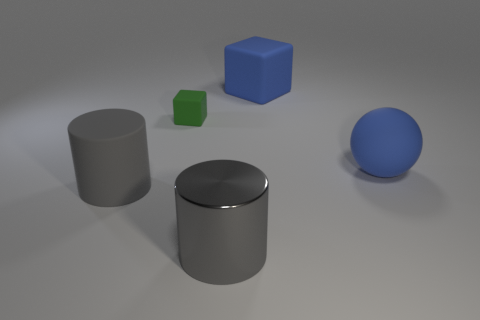Does the large rubber cube have the same color as the matte ball?
Your answer should be compact. Yes. Are there any other things that have the same size as the green block?
Your response must be concise. No. There is a big rubber thing that is behind the big blue sphere; what is its color?
Provide a short and direct response. Blue. What is the size of the gray object that is the same material as the big block?
Make the answer very short. Large. What number of big cylinders are behind the object to the left of the small rubber object?
Make the answer very short. 0. There is a blue rubber ball; what number of big blue objects are in front of it?
Make the answer very short. 0. What color is the big matte object that is in front of the blue matte thing that is on the right side of the large blue rubber thing behind the blue sphere?
Offer a terse response. Gray. Is the color of the matte object behind the tiny block the same as the rubber object to the left of the green matte object?
Offer a terse response. No. There is a blue object that is in front of the blue thing left of the big rubber ball; what is its shape?
Your response must be concise. Sphere. Is there a yellow cylinder of the same size as the gray rubber thing?
Your answer should be compact. No. 